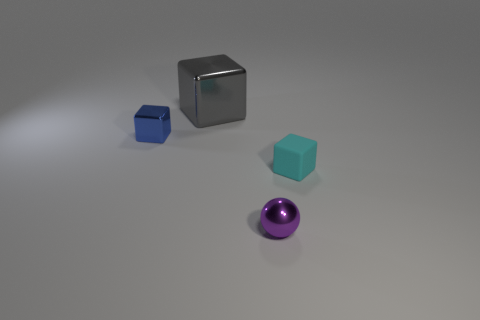How does the size of the silver cube compare to the cyan cube and the sphere? The silver cube is considerably larger than both the cyan cube and the sphere, indicating it's the dominant object in terms of size in this group. 